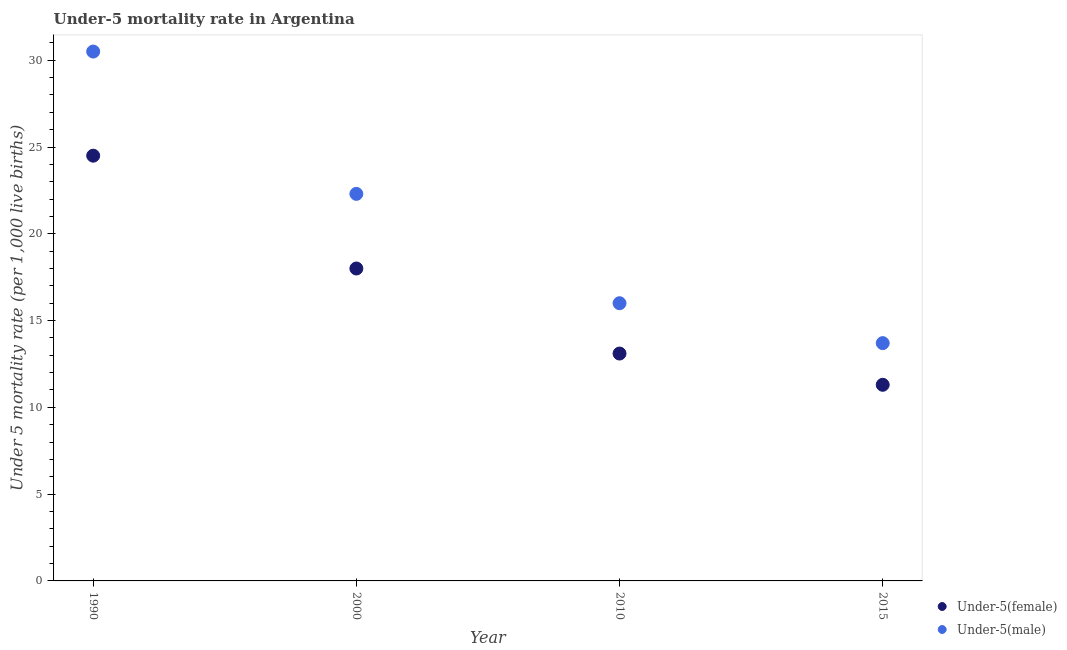Is the number of dotlines equal to the number of legend labels?
Give a very brief answer. Yes. What is the under-5 male mortality rate in 2000?
Your response must be concise. 22.3. Across all years, what is the maximum under-5 female mortality rate?
Your answer should be very brief. 24.5. Across all years, what is the minimum under-5 female mortality rate?
Keep it short and to the point. 11.3. In which year was the under-5 male mortality rate maximum?
Make the answer very short. 1990. In which year was the under-5 male mortality rate minimum?
Your response must be concise. 2015. What is the total under-5 male mortality rate in the graph?
Your answer should be compact. 82.5. What is the difference between the under-5 male mortality rate in 1990 and that in 2010?
Make the answer very short. 14.5. What is the difference between the under-5 female mortality rate in 2010 and the under-5 male mortality rate in 1990?
Give a very brief answer. -17.4. What is the average under-5 female mortality rate per year?
Offer a terse response. 16.73. In the year 2015, what is the difference between the under-5 male mortality rate and under-5 female mortality rate?
Make the answer very short. 2.4. In how many years, is the under-5 male mortality rate greater than 12?
Provide a short and direct response. 4. What is the ratio of the under-5 female mortality rate in 1990 to that in 2015?
Offer a terse response. 2.17. Is the under-5 male mortality rate in 1990 less than that in 2000?
Your response must be concise. No. Is the difference between the under-5 female mortality rate in 2010 and 2015 greater than the difference between the under-5 male mortality rate in 2010 and 2015?
Keep it short and to the point. No. What is the difference between the highest and the second highest under-5 male mortality rate?
Ensure brevity in your answer.  8.2. In how many years, is the under-5 female mortality rate greater than the average under-5 female mortality rate taken over all years?
Offer a very short reply. 2. Are the values on the major ticks of Y-axis written in scientific E-notation?
Ensure brevity in your answer.  No. Where does the legend appear in the graph?
Provide a short and direct response. Bottom right. How are the legend labels stacked?
Your response must be concise. Vertical. What is the title of the graph?
Offer a terse response. Under-5 mortality rate in Argentina. Does "Time to import" appear as one of the legend labels in the graph?
Make the answer very short. No. What is the label or title of the Y-axis?
Give a very brief answer. Under 5 mortality rate (per 1,0 live births). What is the Under 5 mortality rate (per 1,000 live births) in Under-5(male) in 1990?
Give a very brief answer. 30.5. What is the Under 5 mortality rate (per 1,000 live births) in Under-5(male) in 2000?
Your response must be concise. 22.3. What is the Under 5 mortality rate (per 1,000 live births) of Under-5(female) in 2010?
Provide a succinct answer. 13.1. What is the Under 5 mortality rate (per 1,000 live births) of Under-5(male) in 2015?
Your response must be concise. 13.7. Across all years, what is the maximum Under 5 mortality rate (per 1,000 live births) of Under-5(male)?
Offer a very short reply. 30.5. Across all years, what is the minimum Under 5 mortality rate (per 1,000 live births) in Under-5(male)?
Make the answer very short. 13.7. What is the total Under 5 mortality rate (per 1,000 live births) of Under-5(female) in the graph?
Ensure brevity in your answer.  66.9. What is the total Under 5 mortality rate (per 1,000 live births) of Under-5(male) in the graph?
Your answer should be very brief. 82.5. What is the difference between the Under 5 mortality rate (per 1,000 live births) of Under-5(female) in 1990 and that in 2010?
Provide a short and direct response. 11.4. What is the difference between the Under 5 mortality rate (per 1,000 live births) of Under-5(male) in 2000 and that in 2010?
Provide a short and direct response. 6.3. What is the difference between the Under 5 mortality rate (per 1,000 live births) in Under-5(female) in 2000 and that in 2015?
Make the answer very short. 6.7. What is the difference between the Under 5 mortality rate (per 1,000 live births) in Under-5(female) in 2010 and that in 2015?
Your response must be concise. 1.8. What is the difference between the Under 5 mortality rate (per 1,000 live births) in Under-5(male) in 2010 and that in 2015?
Make the answer very short. 2.3. What is the difference between the Under 5 mortality rate (per 1,000 live births) in Under-5(female) in 1990 and the Under 5 mortality rate (per 1,000 live births) in Under-5(male) in 2010?
Ensure brevity in your answer.  8.5. What is the difference between the Under 5 mortality rate (per 1,000 live births) in Under-5(female) in 1990 and the Under 5 mortality rate (per 1,000 live births) in Under-5(male) in 2015?
Keep it short and to the point. 10.8. What is the average Under 5 mortality rate (per 1,000 live births) of Under-5(female) per year?
Provide a succinct answer. 16.73. What is the average Under 5 mortality rate (per 1,000 live births) of Under-5(male) per year?
Provide a succinct answer. 20.62. In the year 1990, what is the difference between the Under 5 mortality rate (per 1,000 live births) in Under-5(female) and Under 5 mortality rate (per 1,000 live births) in Under-5(male)?
Keep it short and to the point. -6. In the year 2000, what is the difference between the Under 5 mortality rate (per 1,000 live births) of Under-5(female) and Under 5 mortality rate (per 1,000 live births) of Under-5(male)?
Keep it short and to the point. -4.3. In the year 2010, what is the difference between the Under 5 mortality rate (per 1,000 live births) in Under-5(female) and Under 5 mortality rate (per 1,000 live births) in Under-5(male)?
Make the answer very short. -2.9. What is the ratio of the Under 5 mortality rate (per 1,000 live births) in Under-5(female) in 1990 to that in 2000?
Your answer should be compact. 1.36. What is the ratio of the Under 5 mortality rate (per 1,000 live births) in Under-5(male) in 1990 to that in 2000?
Your answer should be compact. 1.37. What is the ratio of the Under 5 mortality rate (per 1,000 live births) of Under-5(female) in 1990 to that in 2010?
Your answer should be compact. 1.87. What is the ratio of the Under 5 mortality rate (per 1,000 live births) in Under-5(male) in 1990 to that in 2010?
Your response must be concise. 1.91. What is the ratio of the Under 5 mortality rate (per 1,000 live births) of Under-5(female) in 1990 to that in 2015?
Make the answer very short. 2.17. What is the ratio of the Under 5 mortality rate (per 1,000 live births) in Under-5(male) in 1990 to that in 2015?
Your answer should be very brief. 2.23. What is the ratio of the Under 5 mortality rate (per 1,000 live births) in Under-5(female) in 2000 to that in 2010?
Your answer should be very brief. 1.37. What is the ratio of the Under 5 mortality rate (per 1,000 live births) in Under-5(male) in 2000 to that in 2010?
Ensure brevity in your answer.  1.39. What is the ratio of the Under 5 mortality rate (per 1,000 live births) in Under-5(female) in 2000 to that in 2015?
Offer a terse response. 1.59. What is the ratio of the Under 5 mortality rate (per 1,000 live births) of Under-5(male) in 2000 to that in 2015?
Keep it short and to the point. 1.63. What is the ratio of the Under 5 mortality rate (per 1,000 live births) in Under-5(female) in 2010 to that in 2015?
Make the answer very short. 1.16. What is the ratio of the Under 5 mortality rate (per 1,000 live births) of Under-5(male) in 2010 to that in 2015?
Provide a succinct answer. 1.17. What is the difference between the highest and the second highest Under 5 mortality rate (per 1,000 live births) in Under-5(female)?
Your answer should be very brief. 6.5. What is the difference between the highest and the lowest Under 5 mortality rate (per 1,000 live births) of Under-5(female)?
Ensure brevity in your answer.  13.2. 